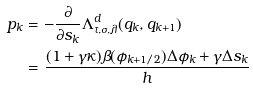<formula> <loc_0><loc_0><loc_500><loc_500>p _ { k } & = - \frac { \partial } { \partial s _ { k } } \Lambda ^ { d } _ { \tau , \sigma , \lambda } ( q _ { k } , q _ { k + 1 } ) \\ & = \frac { ( 1 + \gamma \kappa ) \beta ( \phi _ { k + 1 / 2 } ) \Delta \phi _ { k } + \gamma \Delta s _ { k } } { h }</formula> 